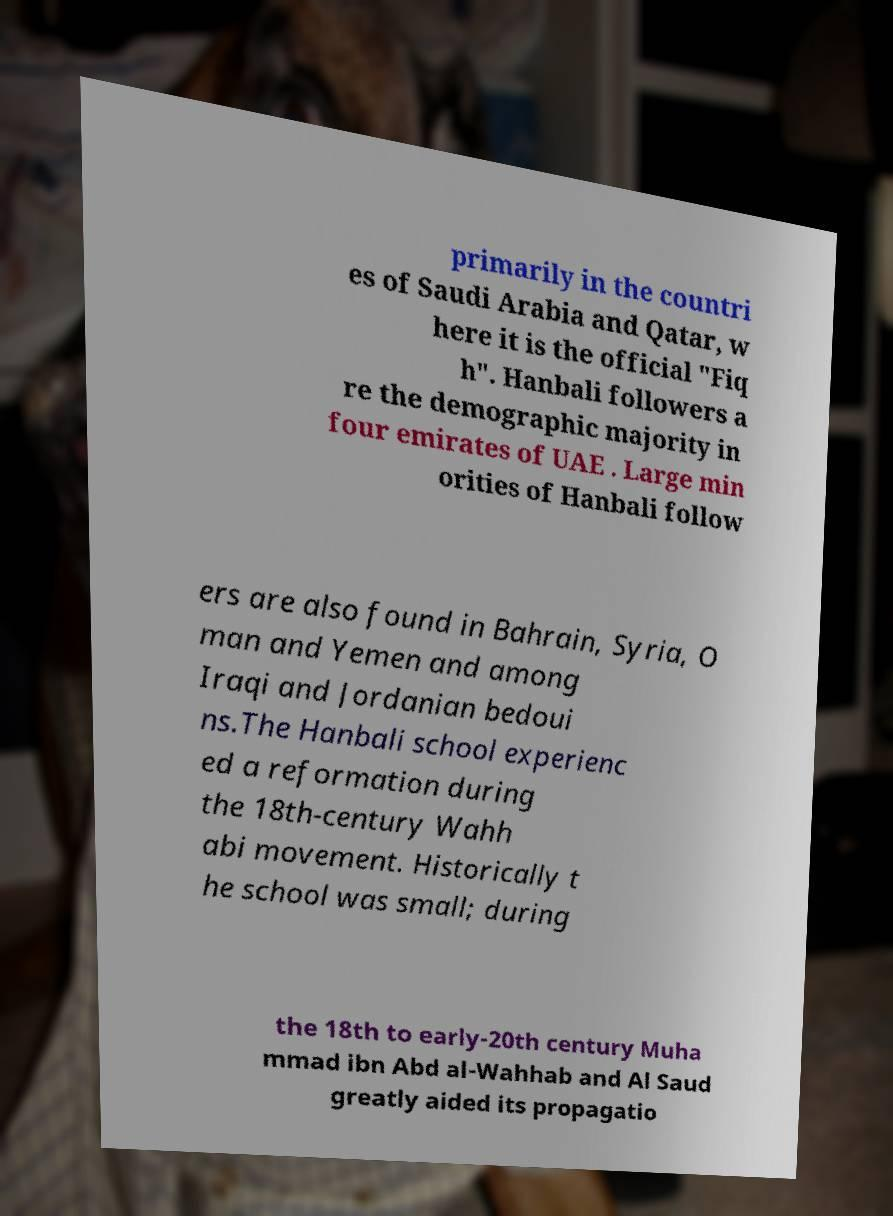Can you accurately transcribe the text from the provided image for me? primarily in the countri es of Saudi Arabia and Qatar, w here it is the official "Fiq h". Hanbali followers a re the demographic majority in four emirates of UAE . Large min orities of Hanbali follow ers are also found in Bahrain, Syria, O man and Yemen and among Iraqi and Jordanian bedoui ns.The Hanbali school experienc ed a reformation during the 18th-century Wahh abi movement. Historically t he school was small; during the 18th to early-20th century Muha mmad ibn Abd al-Wahhab and Al Saud greatly aided its propagatio 